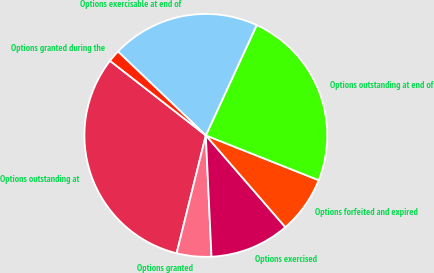<chart> <loc_0><loc_0><loc_500><loc_500><pie_chart><fcel>Options outstanding at<fcel>Options granted<fcel>Options exercised<fcel>Options forfeited and expired<fcel>Options outstanding at end of<fcel>Options exercisable at end of<fcel>Options granted during the<nl><fcel>31.66%<fcel>4.61%<fcel>10.62%<fcel>7.62%<fcel>24.14%<fcel>19.75%<fcel>1.6%<nl></chart> 